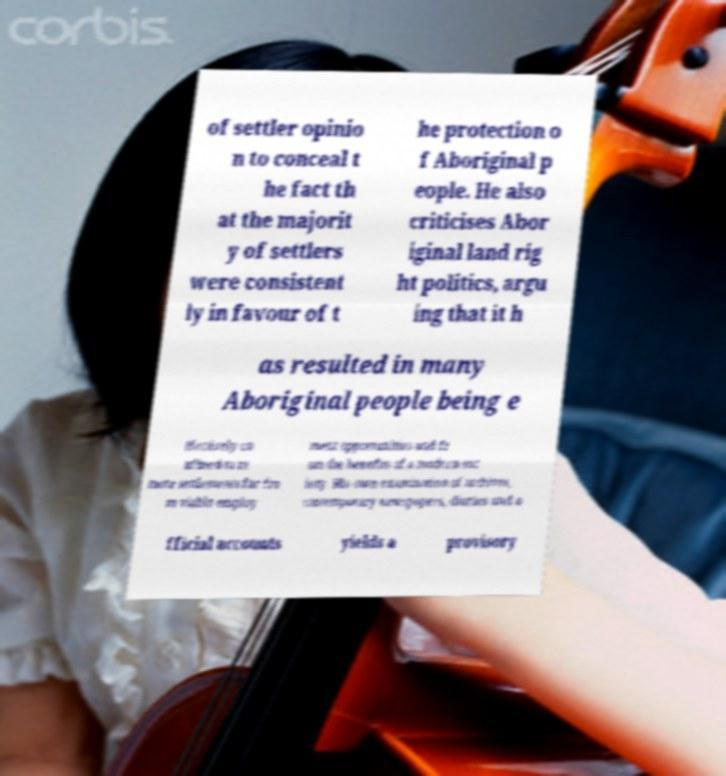Can you read and provide the text displayed in the image?This photo seems to have some interesting text. Can you extract and type it out for me? of settler opinio n to conceal t he fact th at the majorit y of settlers were consistent ly in favour of t he protection o f Aboriginal p eople. He also criticises Abor iginal land rig ht politics, argu ing that it h as resulted in many Aboriginal people being e ffectively co nfined to re mote settlements far fro m viable employ ment opportunities and fr om the benefits of a modern soc iety. His own examination of archives, contemporary newspapers, diaries and o fficial accounts yields a provisory 